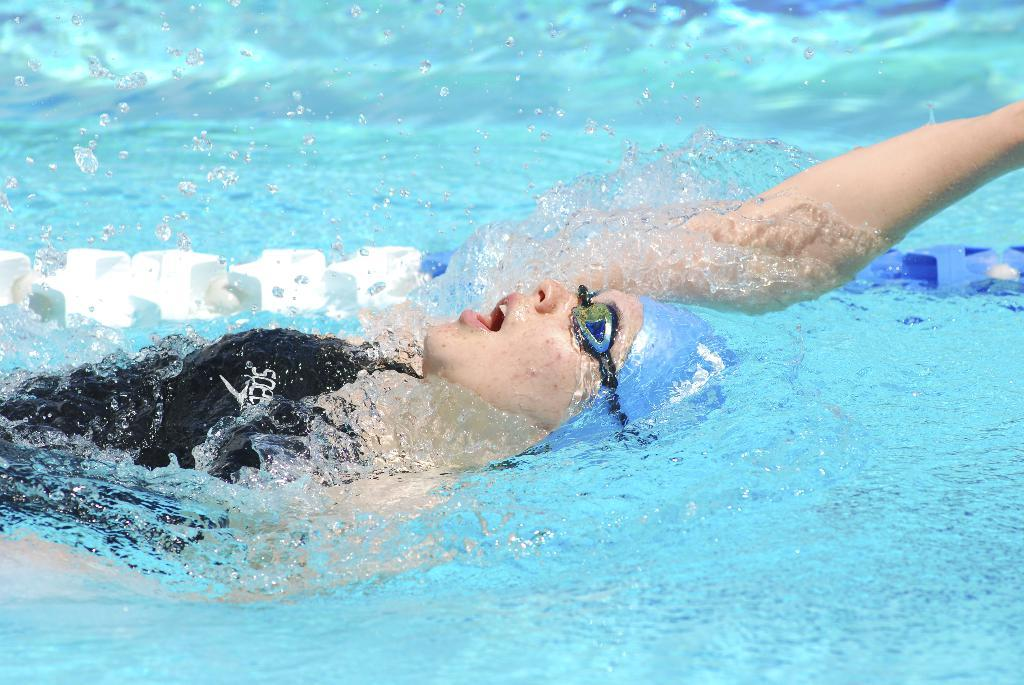What is the main feature of the image? There is a swimming pool in the image. Who or what is in the swimming pool? There is a woman in the swimming pool. What is the woman wearing? The woman is wearing a costume. What is the woman doing in the swimming pool? The woman is swimming. What type of battle is taking place in the swimming pool? There is no battle taking place in the swimming pool; the image only shows a woman swimming. Is the swimming pool surrounded by snow in the image? The image does not indicate any snow or winter conditions; it only shows a woman swimming in a swimming pool. 